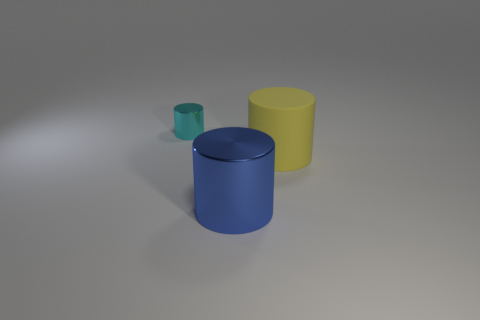Is there anything else that has the same material as the big yellow cylinder?
Your answer should be very brief. No. Are any large red cylinders visible?
Make the answer very short. No. There is a metal cylinder in front of the metal cylinder that is behind the large blue metallic object; how many large yellow cylinders are right of it?
Provide a succinct answer. 1. Is the shape of the large yellow matte thing the same as the metal thing that is to the right of the tiny cyan thing?
Your answer should be very brief. Yes. Are there more big yellow objects than large metal blocks?
Provide a succinct answer. Yes. Is there anything else that has the same size as the cyan cylinder?
Your response must be concise. No. There is a metal thing that is behind the yellow matte cylinder; is its shape the same as the blue shiny thing?
Offer a terse response. Yes. Is the number of small cyan cylinders that are behind the blue metal cylinder greater than the number of cyan shiny things?
Your answer should be very brief. No. What is the color of the metallic thing that is on the right side of the cylinder behind the yellow cylinder?
Your answer should be very brief. Blue. How many big yellow things are there?
Provide a short and direct response. 1. 